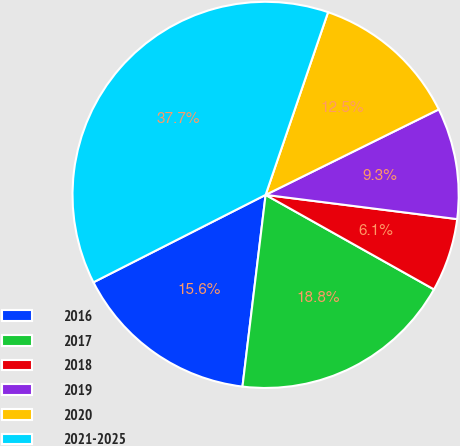Convert chart. <chart><loc_0><loc_0><loc_500><loc_500><pie_chart><fcel>2016<fcel>2017<fcel>2018<fcel>2019<fcel>2020<fcel>2021-2025<nl><fcel>15.61%<fcel>18.77%<fcel>6.14%<fcel>9.3%<fcel>12.46%<fcel>37.72%<nl></chart> 